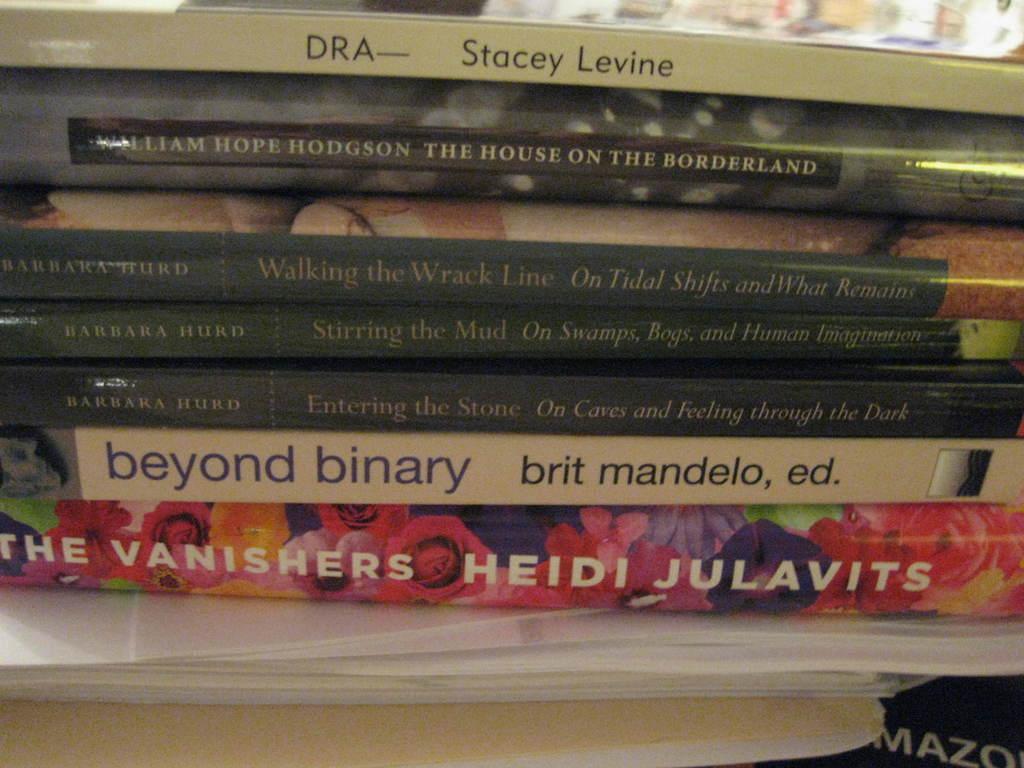Who wrote "the vanishers"?
Your answer should be compact. Heidi julavits. Who wrote "beyond binary"?
Keep it short and to the point. Brit mandelo. 